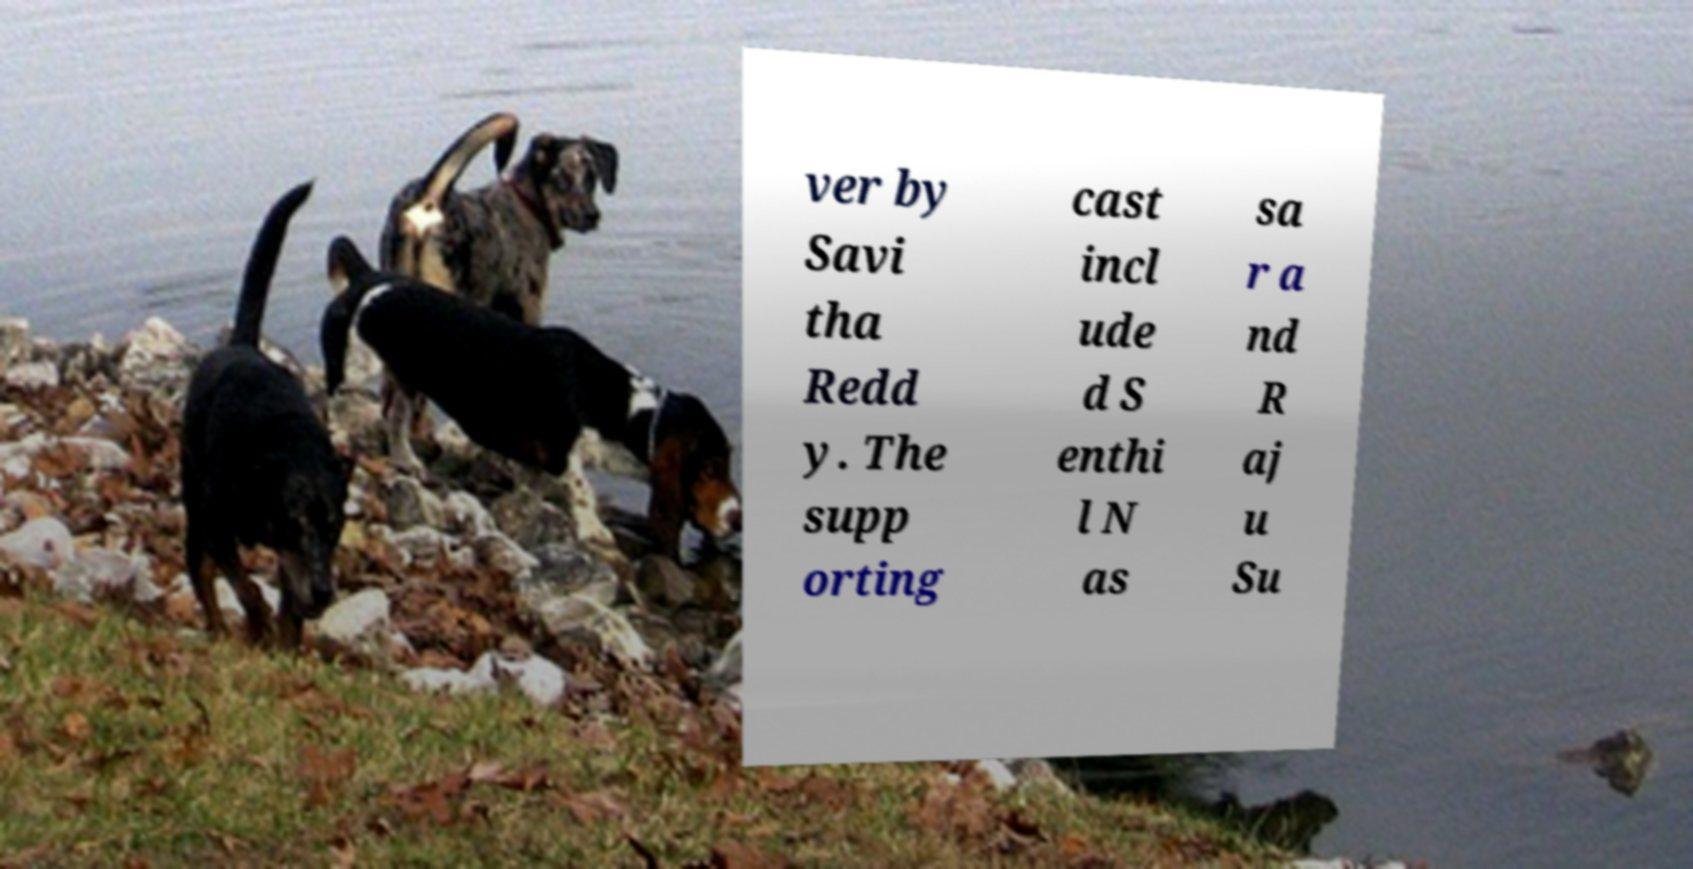For documentation purposes, I need the text within this image transcribed. Could you provide that? ver by Savi tha Redd y. The supp orting cast incl ude d S enthi l N as sa r a nd R aj u Su 